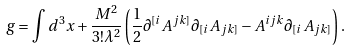<formula> <loc_0><loc_0><loc_500><loc_500>g = \int d ^ { 3 } x + \frac { M ^ { 2 } } { 3 ! \lambda ^ { 2 } } \left ( \frac { 1 } { 2 } \partial ^ { [ i } A ^ { j k ] } \partial _ { [ i } A _ { j k ] } - A ^ { i j k } \partial _ { [ i } A _ { j k ] } \right ) .</formula> 